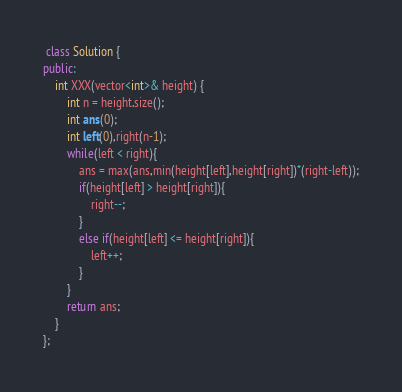<code> <loc_0><loc_0><loc_500><loc_500><_C++_> class Solution {
public:
    int XXX(vector<int>& height) {
        int n = height.size();
        int ans(0);
        int left(0),right(n-1);
        while(left < right){
            ans = max(ans,min(height[left],height[right])*(right-left));
            if(height[left] > height[right]){
                right--;
            }
            else if(height[left] <= height[right]){
                left++;
            }
        }
        return ans;
    }
};

</code> 